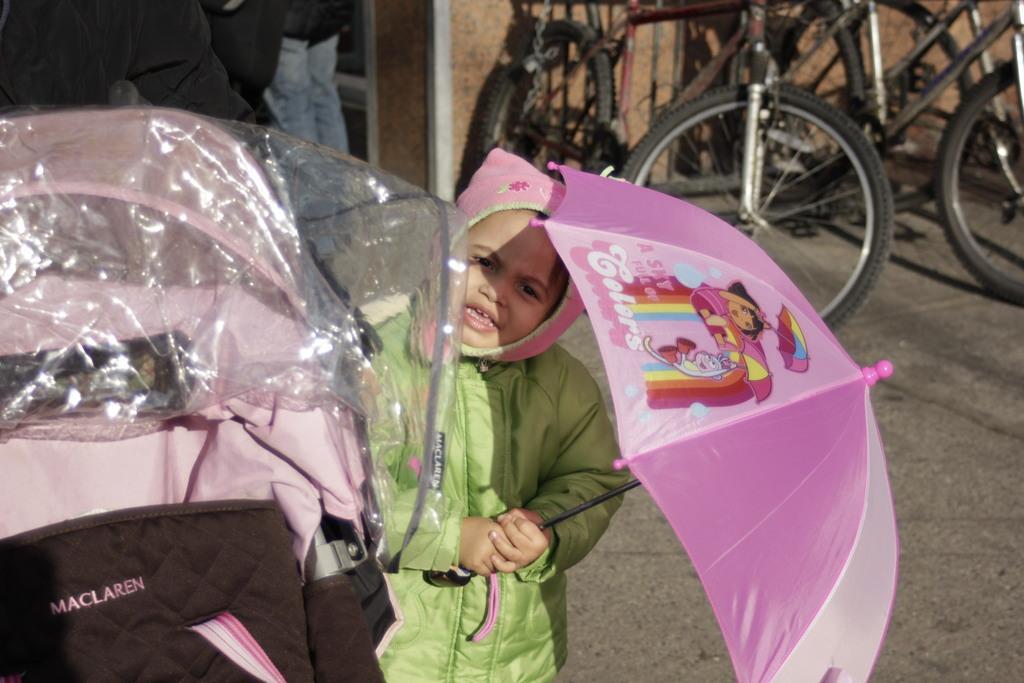In one or two sentences, can you explain what this image depicts? In the image in the center we can see one kid standing and holding pink umbrella and wearing green color jacket. On the left side of the image,there is a plastic cover and one pink and black color object. In the background there is a wall,road,cycles and few people were standing. 